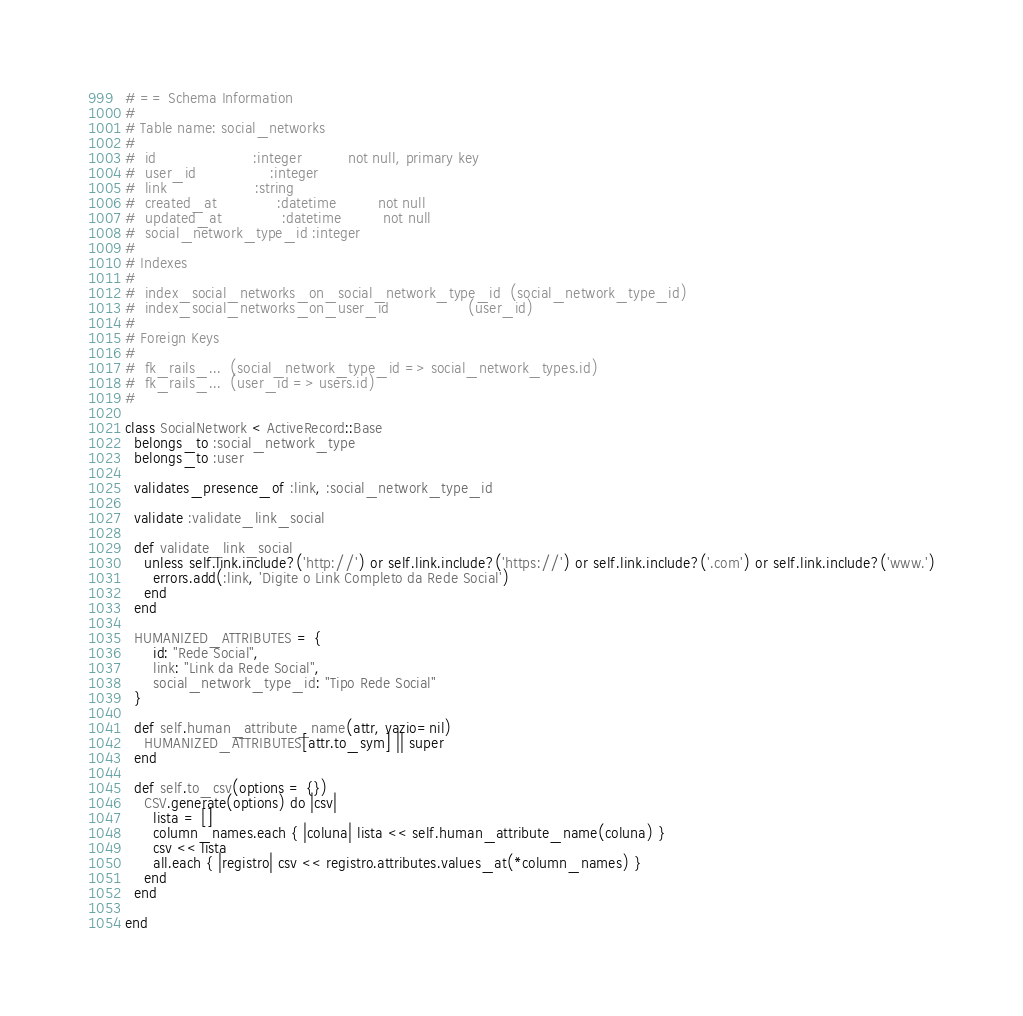<code> <loc_0><loc_0><loc_500><loc_500><_Ruby_># == Schema Information
#
# Table name: social_networks
#
#  id                     :integer          not null, primary key
#  user_id                :integer
#  link                   :string
#  created_at             :datetime         not null
#  updated_at             :datetime         not null
#  social_network_type_id :integer
#
# Indexes
#
#  index_social_networks_on_social_network_type_id  (social_network_type_id)
#  index_social_networks_on_user_id                 (user_id)
#
# Foreign Keys
#
#  fk_rails_...  (social_network_type_id => social_network_types.id)
#  fk_rails_...  (user_id => users.id)
#

class SocialNetwork < ActiveRecord::Base
  belongs_to :social_network_type
  belongs_to :user

  validates_presence_of :link, :social_network_type_id

  validate :validate_link_social

  def validate_link_social
    unless self.link.include?('http://') or self.link.include?('https://') or self.link.include?('.com') or self.link.include?('www.')
      errors.add(:link, 'Digite o Link Completo da Rede Social')
    end
  end

  HUMANIZED_ATTRIBUTES = {
      id: "Rede Social",
      link: "Link da Rede Social",
      social_network_type_id: "Tipo Rede Social"
  }

  def self.human_attribute_name(attr, vazio=nil)
    HUMANIZED_ATTRIBUTES[attr.to_sym] || super
  end

  def self.to_csv(options = {})
    CSV.generate(options) do |csv|
      lista = []
      column_names.each { |coluna| lista << self.human_attribute_name(coluna) }
      csv << lista
      all.each { |registro| csv << registro.attributes.values_at(*column_names) }
    end
  end

end
</code> 